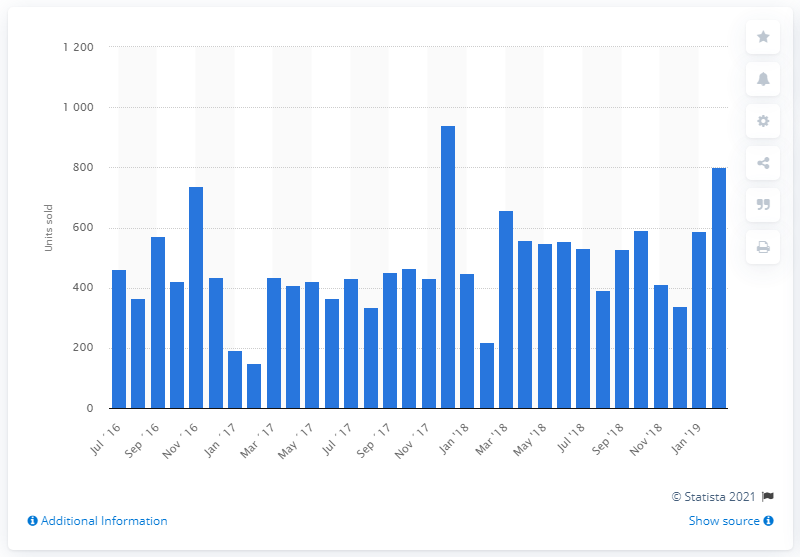Give some essential details in this illustration. In January 2019, a total of 589 motorcycles were sold. 